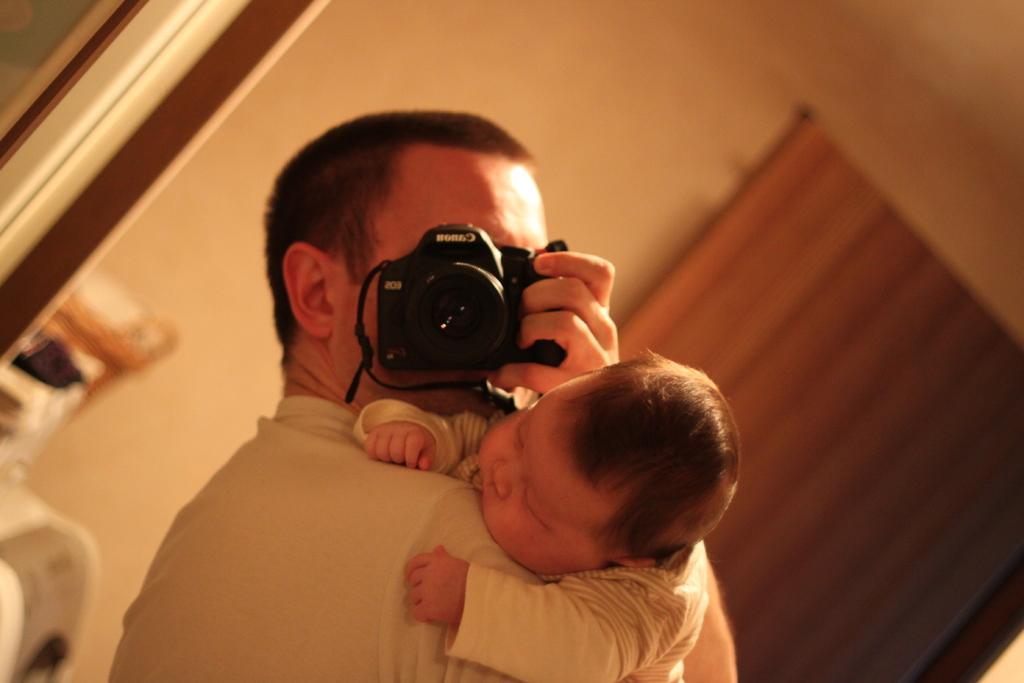In one or two sentences, can you explain what this image depicts? The person is holding a baby in one of his hands and holding a camera in his another hand. 